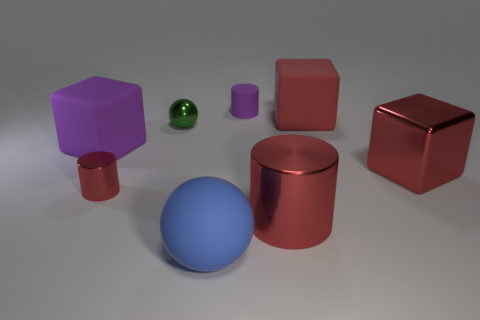Are there any patterns or associations between the objects' colors and shapes? Upon closer examination, the objects' colors do not seem to follow a specific pattern concerning their shapes. There are a variety of shapes such as cylinders, cubes, and spheres, each in different colors. For instance, we can see spheres both in green and blue, cylinders in red and purple, and cubes in red and purple as well. This suggests no direct correlation between an object's color and its shape. 